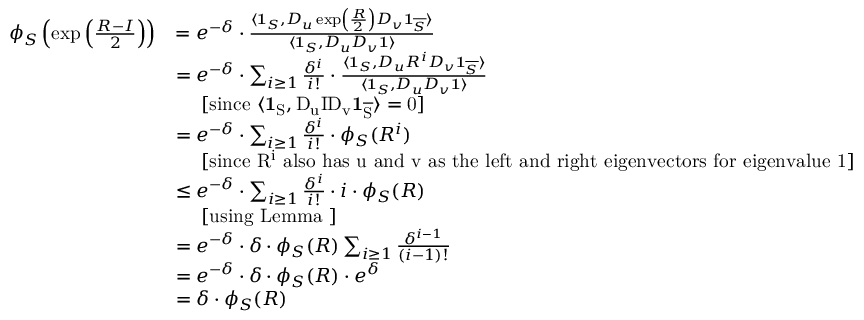<formula> <loc_0><loc_0><loc_500><loc_500>\begin{array} { r l } { \phi _ { S } \left ( \exp \left ( \frac { R - I } { 2 } \right ) \right ) } & { = e ^ { - \delta } \cdot \frac { \langle 1 _ { S } , D _ { u } \exp \left ( \frac { R } { 2 } \right ) D _ { v } 1 _ { \overline { S } } \rangle } { \langle 1 _ { S } , D _ { u } D _ { v } 1 \rangle } } \\ & { = e ^ { - \delta } \cdot \sum _ { i \geq 1 } \frac { \delta ^ { i } } { i ! } \cdot \frac { \langle 1 _ { S } , D _ { u } R ^ { i } D _ { v } 1 _ { \overline { S } } \rangle } { \langle 1 _ { S } , D _ { u } D _ { v } 1 \rangle } } \\ & { \quad [ \sin c e { \langle 1 _ { S } , D _ { u } I D _ { v } 1 _ { \overline { S } } \rangle = 0 } ] } \\ & { = e ^ { - \delta } \cdot \sum _ { i \geq 1 } \frac { \delta ^ { i } } { i ! } \cdot \phi _ { S } ( R ^ { i } ) } \\ & { \quad [ \sin c e { R ^ { i } } a l s o h a s { u } a n d { v } a s t h e l e f t a n d r i g h t e i g e n v e c t o r s f o r e i g e n v a l u e 1 ] } \\ & { \leq e ^ { - \delta } \cdot \sum _ { i \geq 1 } \frac { \delta ^ { i } } { i ! } \cdot i \cdot \phi _ { S } ( R ) } \\ & { \quad [ u \sin g L e m m a ] } \\ & { = e ^ { - \delta } \cdot \delta \cdot \phi _ { S } ( R ) \sum _ { i \geq 1 } \frac { \delta ^ { i - 1 } } { ( i - 1 ) ! } } \\ & { = e ^ { - \delta } \cdot \delta \cdot \phi _ { S } ( R ) \cdot e ^ { \delta } } \\ & { = \delta \cdot \phi _ { S } ( R ) } \end{array}</formula> 